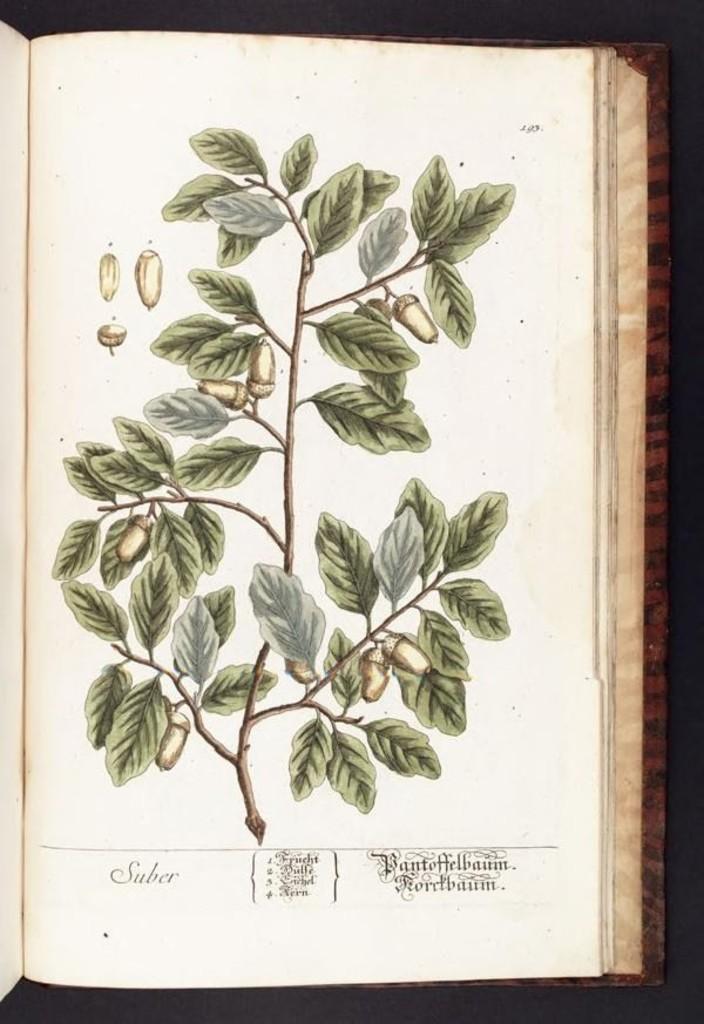Please provide a concise description of this image. There is a drawing of a plant on the page of a book. 